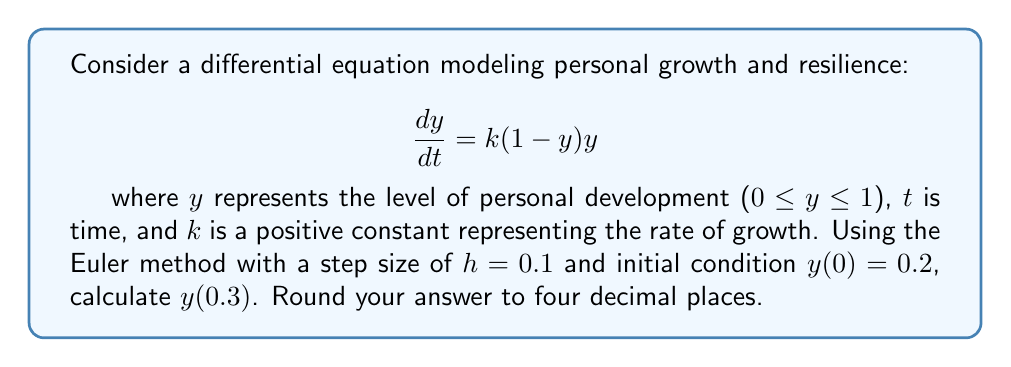Show me your answer to this math problem. To solve this problem using the Euler method, we'll follow these steps:

1) The Euler method is given by the formula:
   $$y_{n+1} = y_n + hf(t_n, y_n)$$
   where $f(t,y) = k(1-y)y$ in our case.

2) We're given $k$ is positive, but not its specific value. Let's assume $k=1$ for this problem.

3) We need to calculate three steps to reach $t=0.3$ from $t=0$ with $h=0.1$.

4) Step 1 ($t=0$ to $t=0.1$):
   $$y_1 = y_0 + h\cdot k(1-y_0)y_0$$
   $$y_1 = 0.2 + 0.1 \cdot 1(1-0.2)0.2 = 0.2 + 0.016 = 0.216$$

5) Step 2 ($t=0.1$ to $t=0.2$):
   $$y_2 = y_1 + h\cdot k(1-y_1)y_1$$
   $$y_2 = 0.216 + 0.1 \cdot 1(1-0.216)0.216 = 0.216 + 0.016934 = 0.232934$$

6) Step 3 ($t=0.2$ to $t=0.3$):
   $$y_3 = y_2 + h\cdot k(1-y_2)y_2$$
   $$y_3 = 0.232934 + 0.1 \cdot 1(1-0.232934)0.232934 = 0.232934 + 0.017863 = 0.250797$$

7) Rounding to four decimal places, we get 0.2508.
Answer: 0.2508 